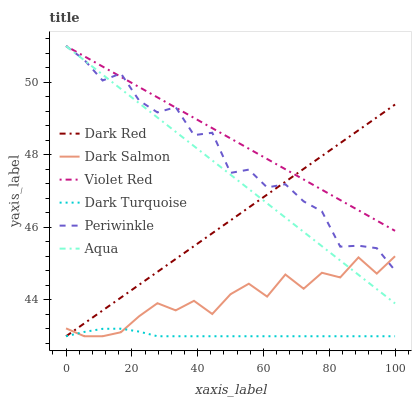Does Dark Turquoise have the minimum area under the curve?
Answer yes or no. Yes. Does Violet Red have the maximum area under the curve?
Answer yes or no. Yes. Does Dark Red have the minimum area under the curve?
Answer yes or no. No. Does Dark Red have the maximum area under the curve?
Answer yes or no. No. Is Aqua the smoothest?
Answer yes or no. Yes. Is Periwinkle the roughest?
Answer yes or no. Yes. Is Dark Red the smoothest?
Answer yes or no. No. Is Dark Red the roughest?
Answer yes or no. No. Does Dark Red have the lowest value?
Answer yes or no. Yes. Does Aqua have the lowest value?
Answer yes or no. No. Does Periwinkle have the highest value?
Answer yes or no. Yes. Does Dark Red have the highest value?
Answer yes or no. No. Is Dark Turquoise less than Aqua?
Answer yes or no. Yes. Is Violet Red greater than Dark Turquoise?
Answer yes or no. Yes. Does Dark Turquoise intersect Dark Red?
Answer yes or no. Yes. Is Dark Turquoise less than Dark Red?
Answer yes or no. No. Is Dark Turquoise greater than Dark Red?
Answer yes or no. No. Does Dark Turquoise intersect Aqua?
Answer yes or no. No. 